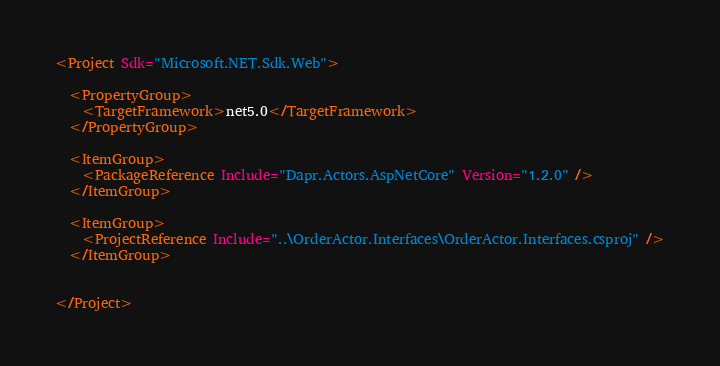<code> <loc_0><loc_0><loc_500><loc_500><_XML_><Project Sdk="Microsoft.NET.Sdk.Web">

  <PropertyGroup>
    <TargetFramework>net5.0</TargetFramework>
  </PropertyGroup>

  <ItemGroup>
    <PackageReference Include="Dapr.Actors.AspNetCore" Version="1.2.0" />
  </ItemGroup>

  <ItemGroup>
    <ProjectReference Include="..\OrderActor.Interfaces\OrderActor.Interfaces.csproj" />
  </ItemGroup>


</Project>
</code> 